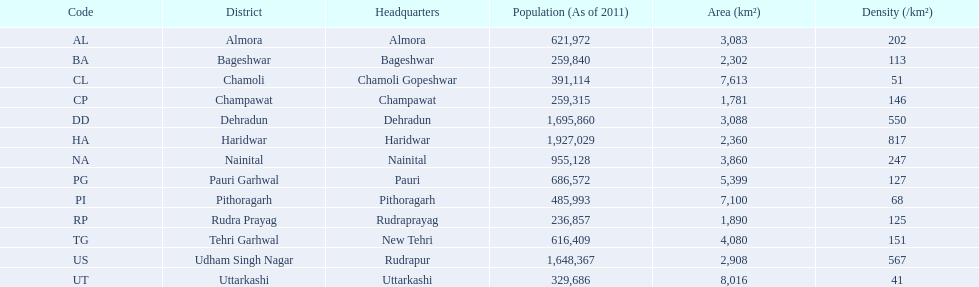What are all the districts? Almora, Bageshwar, Chamoli, Champawat, Dehradun, Haridwar, Nainital, Pauri Garhwal, Pithoragarh, Rudra Prayag, Tehri Garhwal, Udham Singh Nagar, Uttarkashi. And their densities? 202, 113, 51, 146, 550, 817, 247, 127, 68, 125, 151, 567, 41. Now, which district's density is 51? Chamoli. 